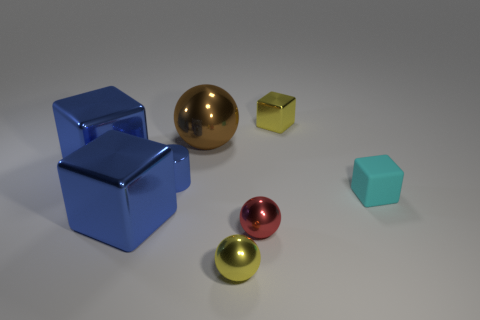Add 2 red metallic spheres. How many objects exist? 10 Subtract all balls. How many objects are left? 5 Add 4 purple cylinders. How many purple cylinders exist? 4 Subtract 0 purple blocks. How many objects are left? 8 Subtract all large metal balls. Subtract all small metallic cylinders. How many objects are left? 6 Add 5 blue cubes. How many blue cubes are left? 7 